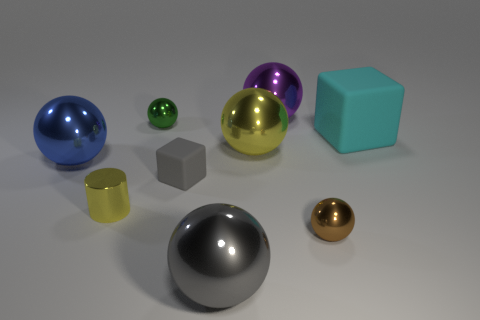Subtract all gray balls. How many balls are left? 5 Subtract all brown balls. How many balls are left? 5 Subtract all purple spheres. Subtract all purple cylinders. How many spheres are left? 5 Add 1 gray things. How many objects exist? 10 Subtract all cylinders. How many objects are left? 8 Subtract all large green metallic objects. Subtract all blue shiny balls. How many objects are left? 8 Add 6 big cubes. How many big cubes are left? 7 Add 8 green rubber things. How many green rubber things exist? 8 Subtract 1 yellow cylinders. How many objects are left? 8 